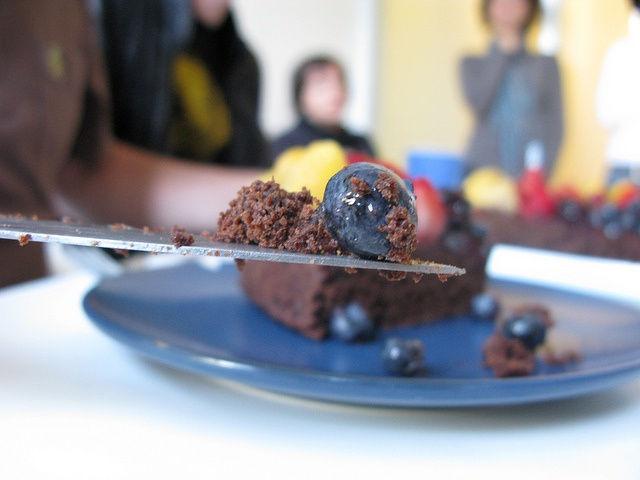Describe the objects in this image and their specific colors. I can see dining table in black, white, gray, and darkgray tones, people in black, gray, and maroon tones, cake in black and gray tones, people in black and gray tones, and people in black, olive, and gray tones in this image. 